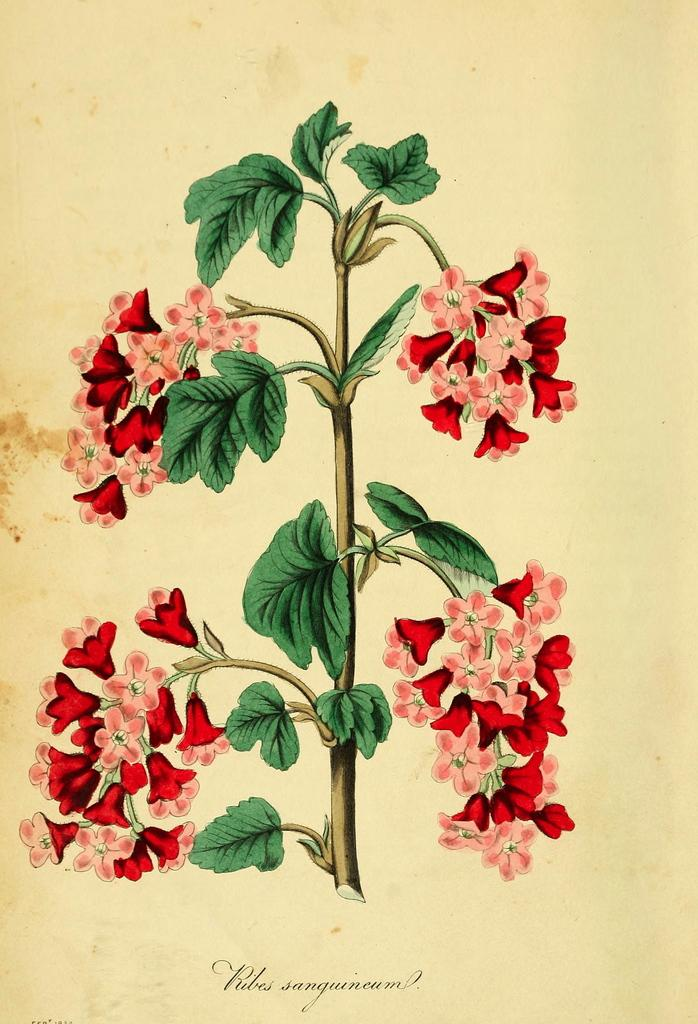What is featured on the poster in the image? There is a poster in the image, and it contains a plant with flowers. What else can be seen on the poster besides the plant with flowers? There is text present on the poster. What type of baby is depicted in the image? There is no baby present in the image; it features a poster with a plant and text. What kind of discussion is taking place in the image? There is no discussion taking place in the image; it features a poster with a plant and text. 